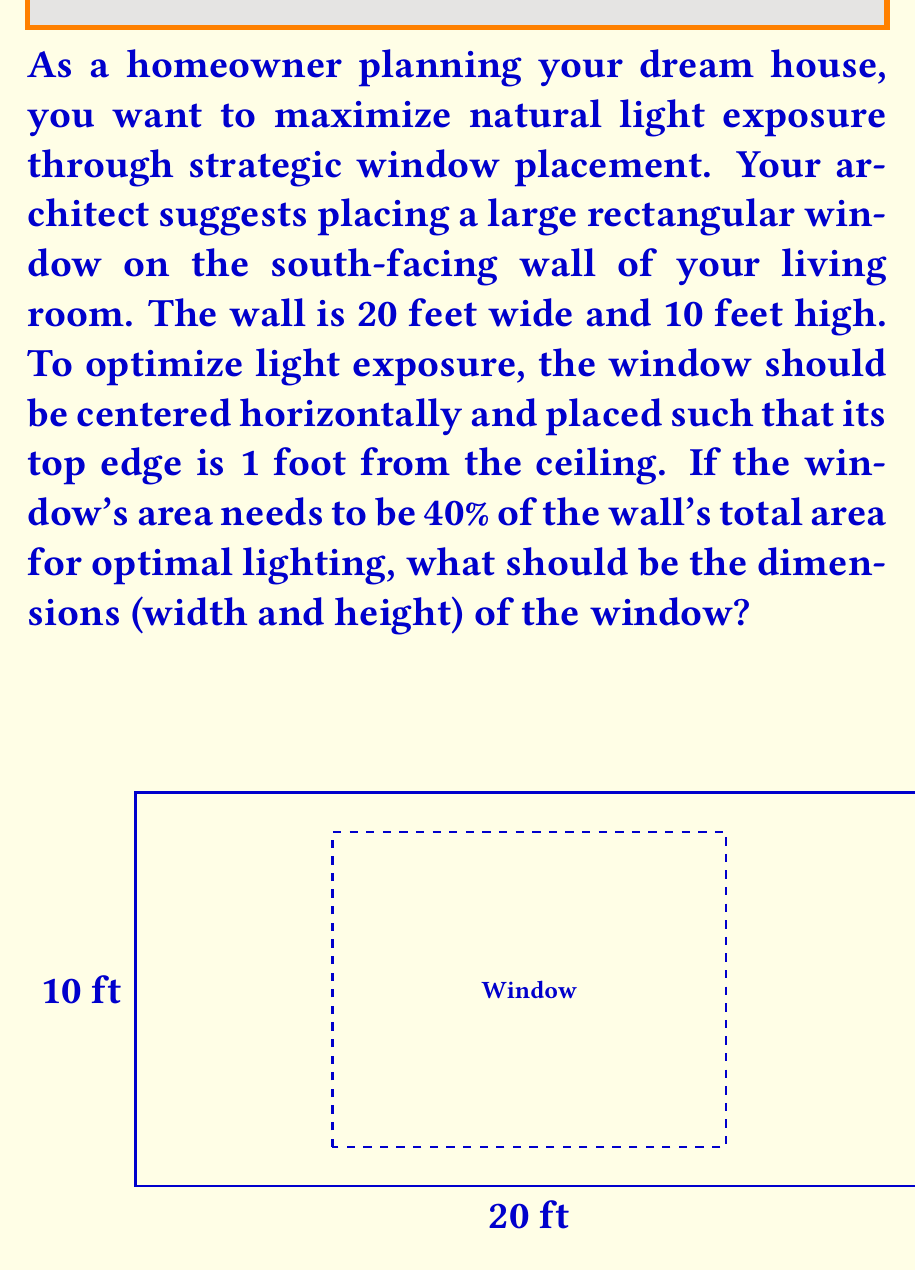Could you help me with this problem? Let's approach this step-by-step:

1) First, calculate the total area of the wall:
   $A_{wall} = 20 \text{ ft} \times 10 \text{ ft} = 200 \text{ sq ft}$

2) The window area should be 40% of the wall area:
   $A_{window} = 40\% \times 200 \text{ sq ft} = 0.4 \times 200 \text{ sq ft} = 80 \text{ sq ft}$

3) Let the width of the window be $w$ and the height be $h$. We know:
   $w \times h = 80 \text{ sq ft}$

4) The window should be 1 foot from the ceiling, so its height is:
   $h = 10 \text{ ft} - 1 \text{ ft} = 9 \text{ ft}$

5) Now we can solve for the width:
   $w \times 9 \text{ ft} = 80 \text{ sq ft}$
   $w = \frac{80 \text{ sq ft}}{9 \text{ ft}} = \frac{80}{9} \text{ ft} \approx 8.89 \text{ ft}$

6) To center the window horizontally, calculate the space on each side:
   $\text{Space on each side} = \frac{20 \text{ ft} - 8.89 \text{ ft}}{2} \approx 5.56 \text{ ft}$

Therefore, the optimal window dimensions are approximately 8.89 feet wide and 9 feet high, centered horizontally on the wall with its top edge 1 foot from the ceiling.
Answer: The optimal window dimensions are approximately 8.89 feet (or 8 feet 10.67 inches) wide and 9 feet high. 